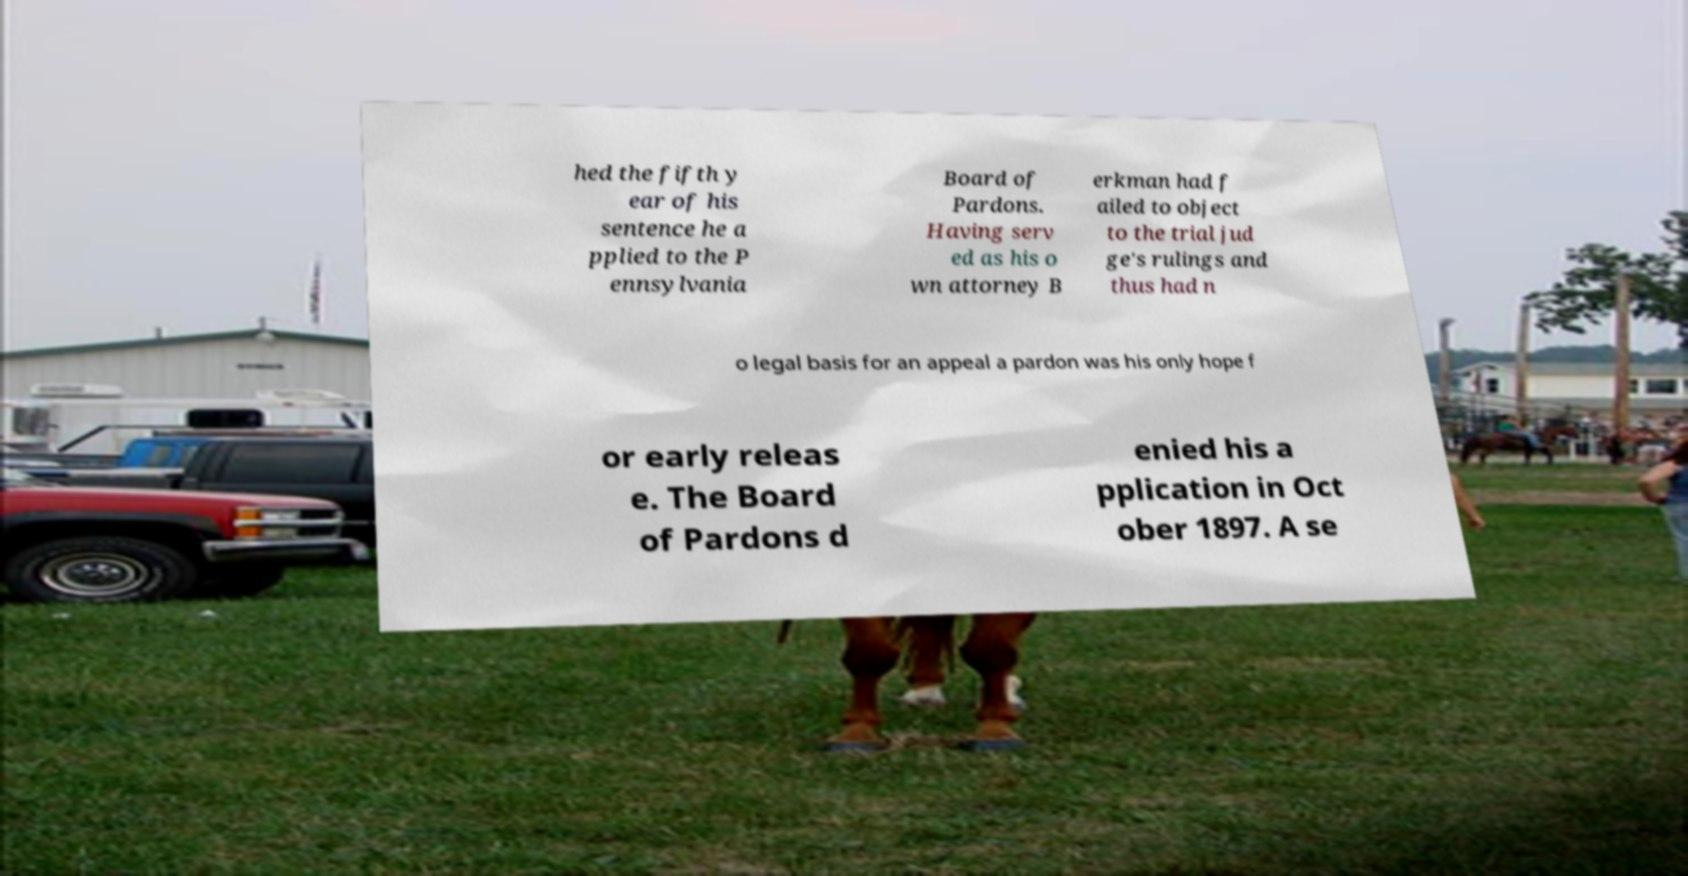What messages or text are displayed in this image? I need them in a readable, typed format. hed the fifth y ear of his sentence he a pplied to the P ennsylvania Board of Pardons. Having serv ed as his o wn attorney B erkman had f ailed to object to the trial jud ge's rulings and thus had n o legal basis for an appeal a pardon was his only hope f or early releas e. The Board of Pardons d enied his a pplication in Oct ober 1897. A se 